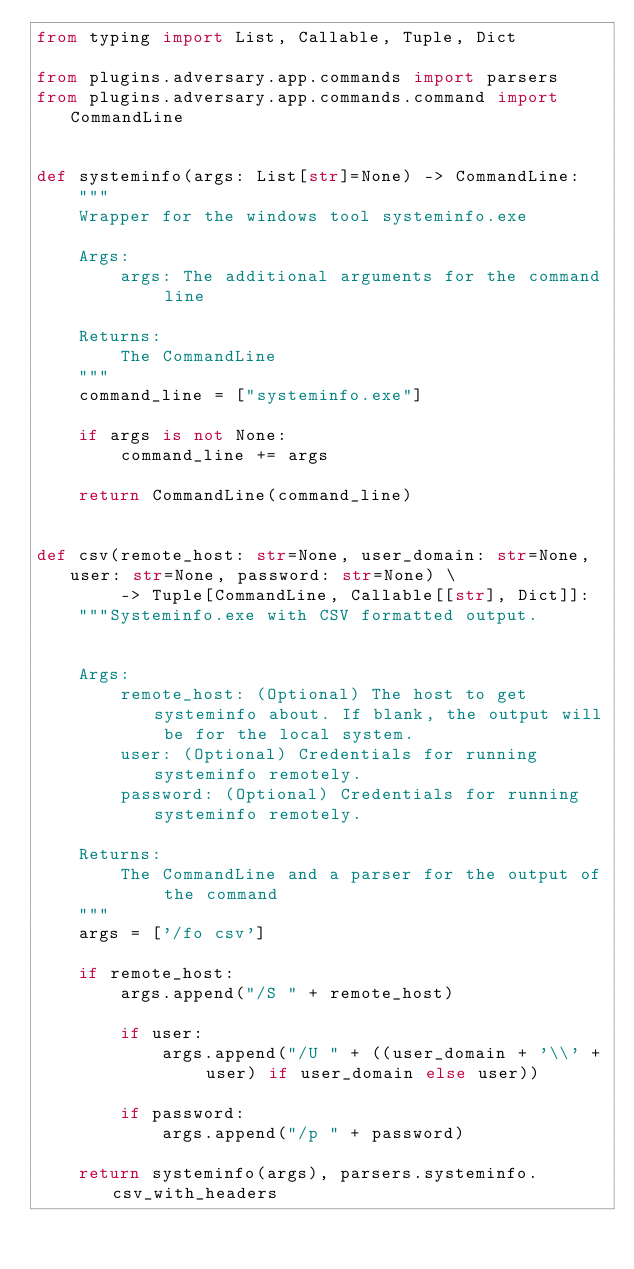<code> <loc_0><loc_0><loc_500><loc_500><_Python_>from typing import List, Callable, Tuple, Dict

from plugins.adversary.app.commands import parsers
from plugins.adversary.app.commands.command import CommandLine


def systeminfo(args: List[str]=None) -> CommandLine:
    """
    Wrapper for the windows tool systeminfo.exe

    Args:
        args: The additional arguments for the command line

    Returns:
        The CommandLine
    """
    command_line = ["systeminfo.exe"]

    if args is not None:
        command_line += args

    return CommandLine(command_line)


def csv(remote_host: str=None, user_domain: str=None, user: str=None, password: str=None) \
        -> Tuple[CommandLine, Callable[[str], Dict]]:
    """Systeminfo.exe with CSV formatted output.


    Args:
        remote_host: (Optional) The host to get systeminfo about. If blank, the output will be for the local system.
        user: (Optional) Credentials for running systeminfo remotely.
        password: (Optional) Credentials for running systeminfo remotely.

    Returns:
        The CommandLine and a parser for the output of the command
    """
    args = ['/fo csv']

    if remote_host:
        args.append("/S " + remote_host)

        if user:
            args.append("/U " + ((user_domain + '\\' + user) if user_domain else user))

        if password:
            args.append("/p " + password)

    return systeminfo(args), parsers.systeminfo.csv_with_headers
</code> 